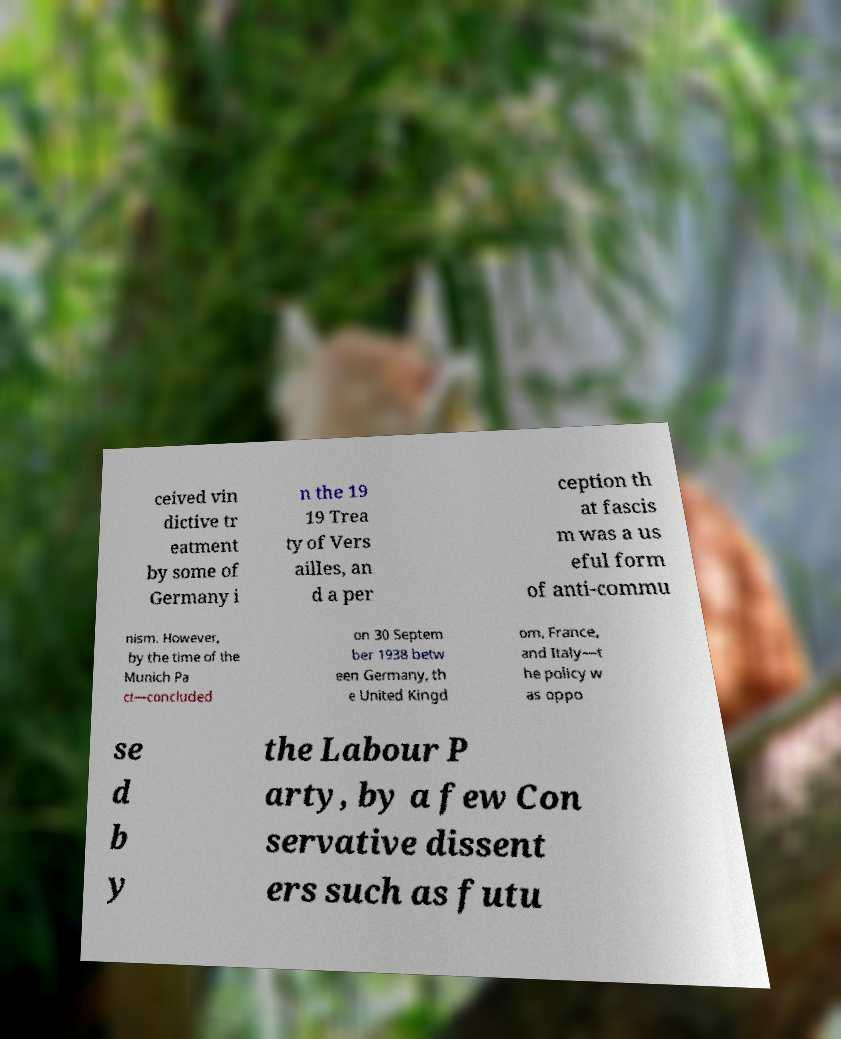What messages or text are displayed in this image? I need them in a readable, typed format. ceived vin dictive tr eatment by some of Germany i n the 19 19 Trea ty of Vers ailles, an d a per ception th at fascis m was a us eful form of anti-commu nism. However, by the time of the Munich Pa ct—concluded on 30 Septem ber 1938 betw een Germany, th e United Kingd om, France, and Italy—t he policy w as oppo se d b y the Labour P arty, by a few Con servative dissent ers such as futu 